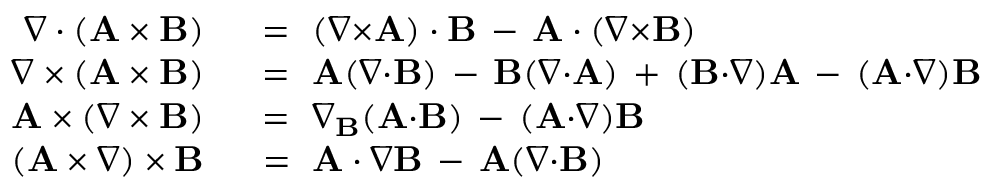<formula> <loc_0><loc_0><loc_500><loc_500>\begin{array} { r l } { \nabla \cdot ( A \times B ) } & \ = \ ( \nabla { \times } A ) \cdot B \, - \, A \cdot ( \nabla { \times } B ) } \\ { \nabla \times ( A \times B ) } & \ = \ A ( \nabla { \cdot } B ) \, - \, B ( \nabla { \cdot } A ) \, + \, ( B { \cdot } \nabla ) A \, - \, ( A { \cdot } \nabla ) B } \\ { A \times ( \nabla \times B ) } & \ = \ \nabla _ { B } ( A { \cdot } B ) \, - \, ( A { \cdot } \nabla ) B } \\ { ( A \times \nabla ) \times B } & \ = \ A \cdot \nabla B \, - \, A ( \nabla { \cdot } B ) } \end{array}</formula> 